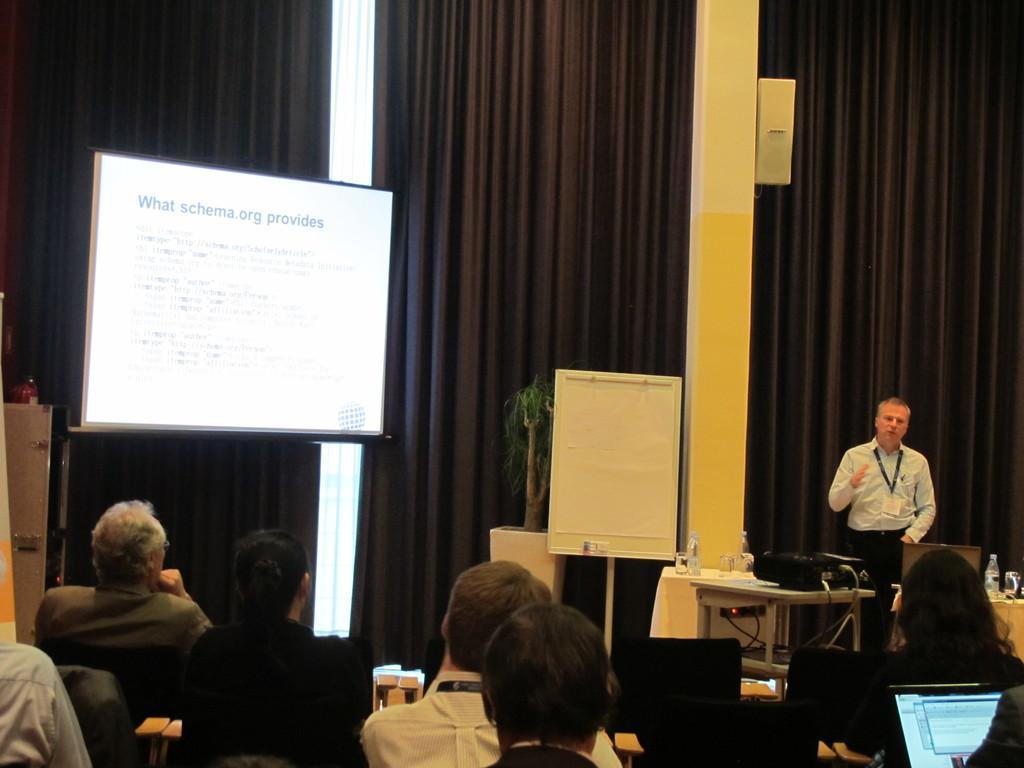Can you describe this image briefly? In this picture we can see a group of people, here we can see laptops, bottles, projector screen, projector, houseplant and some objects and in the background we can see a curtain. 